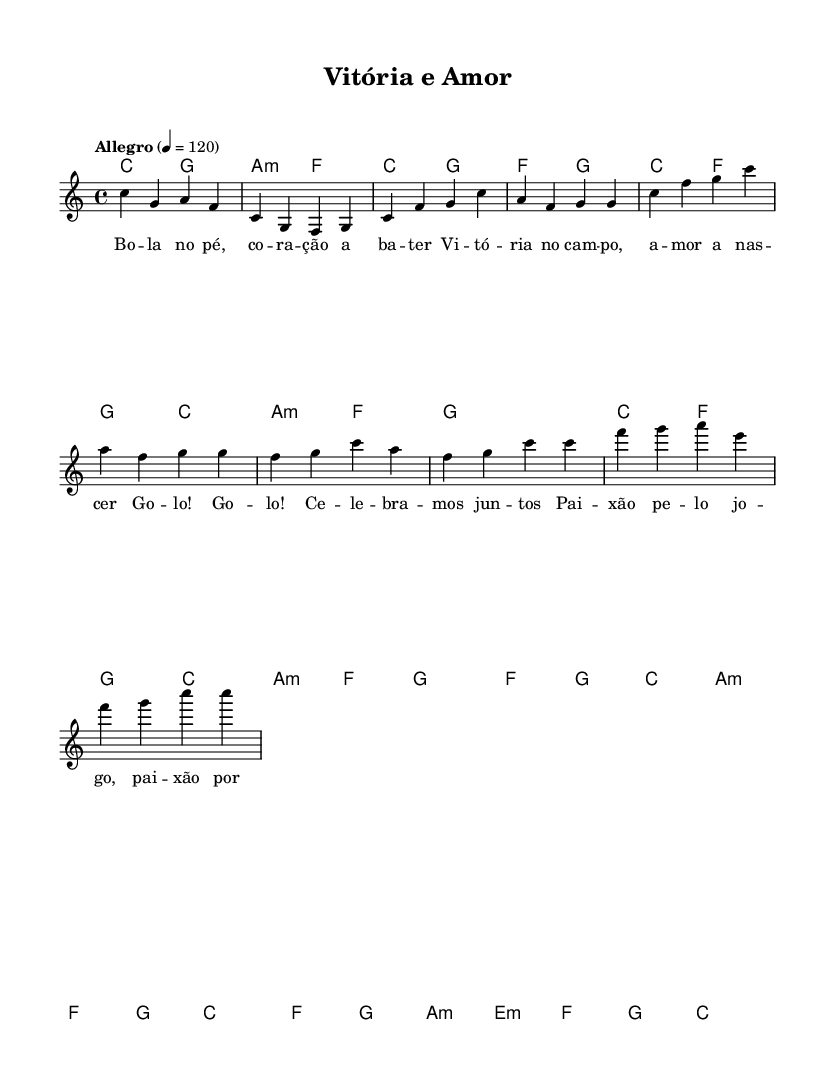What is the key signature of this music? The key signature is indicated at the beginning of the score with a "c" symbol, meaning it is C major, which has no sharps or flats.
Answer: C major What is the time signature of this music? The time signature is presented as "4/4" at the beginning of the score, indicating that there are four beats in each measure and the quarter note gets one beat.
Answer: 4/4 What is the tempo marking for this piece? The tempo marking is found in the score as "Allegro" and is set to 120 beats per minute, indicating a fast and lively tempo.
Answer: Allegro 4 = 120 How many measures are in the chorus section of the song? By counting the measures in the chorus part from the score, there are a total of 8 measures: four measures in the first line and four measures in the second line.
Answer: 8 What is the first word of the lyrics? The first word of the lyrics is derived from the verse words, where "Bo" is the initial word of the first line in the lyrics.
Answer: Bo Which phrase follows "Go -- lo!" in the chorus? Looking at the lyric section for the chorus, the phrase immediately following "Go -- lo!" is "Go -- lo!", as it repeats in the lyrics.
Answer: Go -- lo! What is the final chord in the piece? The last measure of the score indicates a "c1" chord, which signifies that the piece ends on a C major chord, being played as a whole note.
Answer: c1 